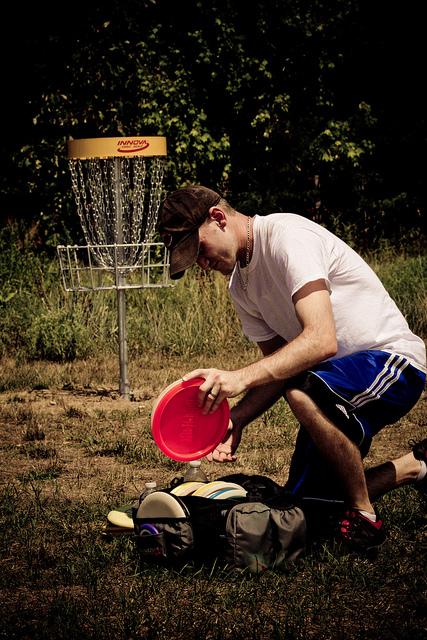Is this man preparing to play ultimate frisbee or disk golf?
Write a very short answer. Disc golf. This man a professional athlete?
Answer briefly. No. How many white vertical stripes are on the man's shorts?
Short answer required. 3. 